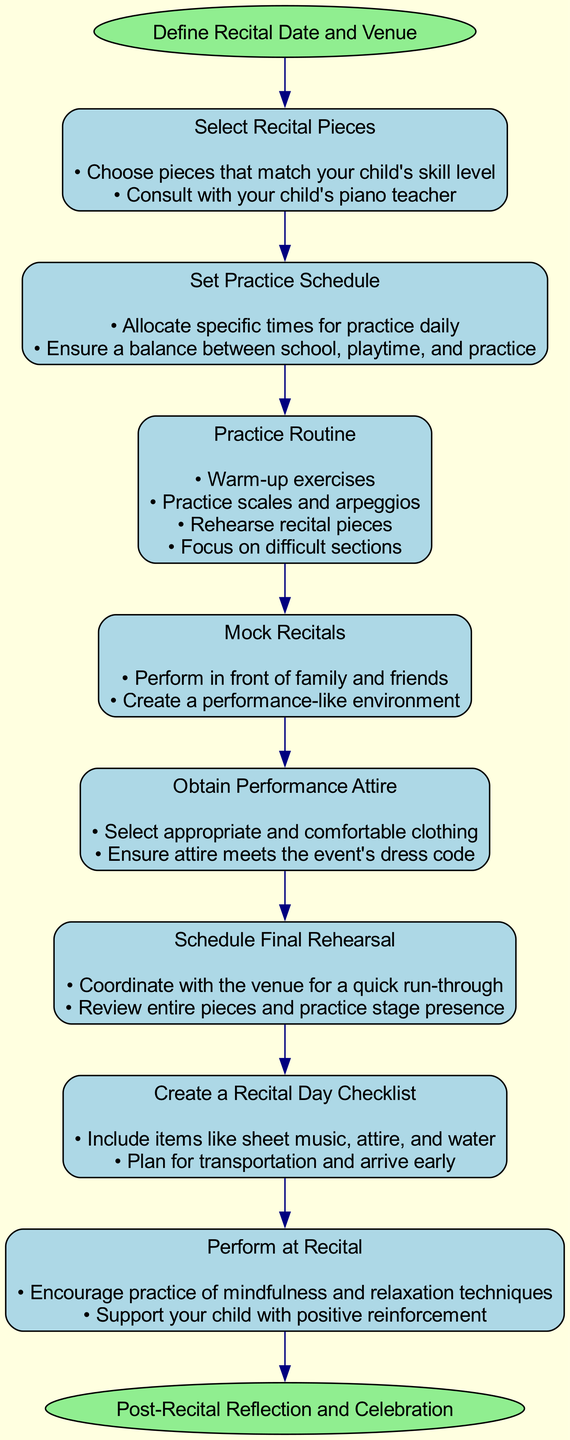What is the first step in preparing for a recital performance? The first step shown in the diagram is "Define Recital Date and Venue", indicating that establishing when and where the recital will occur comes before other preparations.
Answer: Define Recital Date and Venue How many main elements are there in the preparation process? By counting the nodes for each of the main elements of preparation in the diagram, there are 8 elements that outline the steps required to prepare for the recital.
Answer: 8 What are the final preparations listed before performing at the recital? The last preparations outlined before the performance include scheduling a final rehearsal and creating a recital day checklist, as indicated by their order in the flow chart.
Answer: Schedule Final Rehearsal, Create a Recital Day Checklist Which element follows "Set Practice Schedule"? The flow diagram shows that after "Set Practice Schedule", the next step is "Practice Routine", indicating the importance of establishing a set routine after planning out the schedule.
Answer: Practice Routine What two aspects are emphasized in the "Perform at Recital" stage? The diagram specifies focusing on mindfulness and relaxation techniques, along with providing positive reinforcement as key aspects during the performance stage.
Answer: Mindfulness techniques, Positive reinforcement In what position does "Mock Recitals" appear in the preparation sequence? By analyzing the layout of the diagram, "Mock Recitals" is the fourth element, showing that it is introduced after practicing the set pieces and is important for simulating the recital environment.
Answer: Fourth What is the relationship between the "Start" node and the first main element? The flow chart indicates a direct connection from the "Start" node to "Select Recital Pieces", meaning the first action takes place immediately after defining the date and venue.
Answer: Direct connection How does the diagram conclude the preparation process? The diagram concludes by indicating "Post-Recital Reflection and Celebration" as the final stage, which occurs after all other activities, emphasizing the importance of reflecting on the performance.
Answer: Post-Recital Reflection and Celebration 